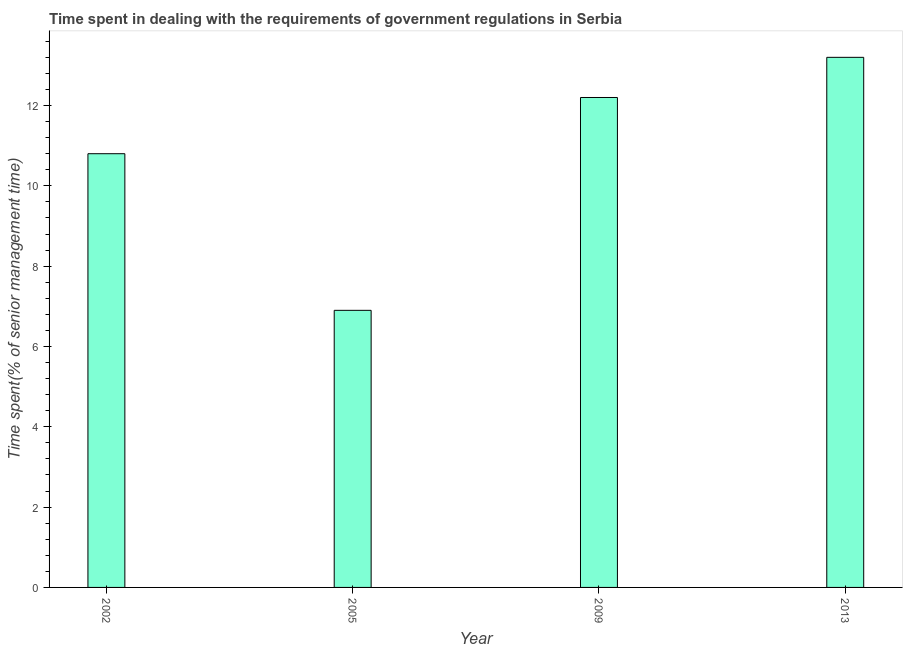Does the graph contain grids?
Ensure brevity in your answer.  No. What is the title of the graph?
Your answer should be very brief. Time spent in dealing with the requirements of government regulations in Serbia. What is the label or title of the Y-axis?
Give a very brief answer. Time spent(% of senior management time). What is the time spent in dealing with government regulations in 2009?
Keep it short and to the point. 12.2. Across all years, what is the maximum time spent in dealing with government regulations?
Your answer should be very brief. 13.2. In which year was the time spent in dealing with government regulations maximum?
Provide a succinct answer. 2013. In which year was the time spent in dealing with government regulations minimum?
Offer a very short reply. 2005. What is the sum of the time spent in dealing with government regulations?
Your answer should be compact. 43.1. What is the difference between the time spent in dealing with government regulations in 2005 and 2013?
Your answer should be compact. -6.3. What is the average time spent in dealing with government regulations per year?
Your response must be concise. 10.78. What is the median time spent in dealing with government regulations?
Your response must be concise. 11.5. Do a majority of the years between 2013 and 2005 (inclusive) have time spent in dealing with government regulations greater than 8.4 %?
Keep it short and to the point. Yes. What is the ratio of the time spent in dealing with government regulations in 2002 to that in 2005?
Provide a succinct answer. 1.56. Is the time spent in dealing with government regulations in 2005 less than that in 2009?
Give a very brief answer. Yes. Is the sum of the time spent in dealing with government regulations in 2005 and 2009 greater than the maximum time spent in dealing with government regulations across all years?
Offer a terse response. Yes. In how many years, is the time spent in dealing with government regulations greater than the average time spent in dealing with government regulations taken over all years?
Ensure brevity in your answer.  3. How many years are there in the graph?
Keep it short and to the point. 4. Are the values on the major ticks of Y-axis written in scientific E-notation?
Provide a succinct answer. No. What is the Time spent(% of senior management time) of 2005?
Give a very brief answer. 6.9. What is the Time spent(% of senior management time) of 2013?
Make the answer very short. 13.2. What is the difference between the Time spent(% of senior management time) in 2002 and 2009?
Give a very brief answer. -1.4. What is the difference between the Time spent(% of senior management time) in 2005 and 2009?
Make the answer very short. -5.3. What is the difference between the Time spent(% of senior management time) in 2009 and 2013?
Your response must be concise. -1. What is the ratio of the Time spent(% of senior management time) in 2002 to that in 2005?
Your response must be concise. 1.56. What is the ratio of the Time spent(% of senior management time) in 2002 to that in 2009?
Your answer should be very brief. 0.89. What is the ratio of the Time spent(% of senior management time) in 2002 to that in 2013?
Offer a terse response. 0.82. What is the ratio of the Time spent(% of senior management time) in 2005 to that in 2009?
Provide a succinct answer. 0.57. What is the ratio of the Time spent(% of senior management time) in 2005 to that in 2013?
Offer a terse response. 0.52. What is the ratio of the Time spent(% of senior management time) in 2009 to that in 2013?
Keep it short and to the point. 0.92. 